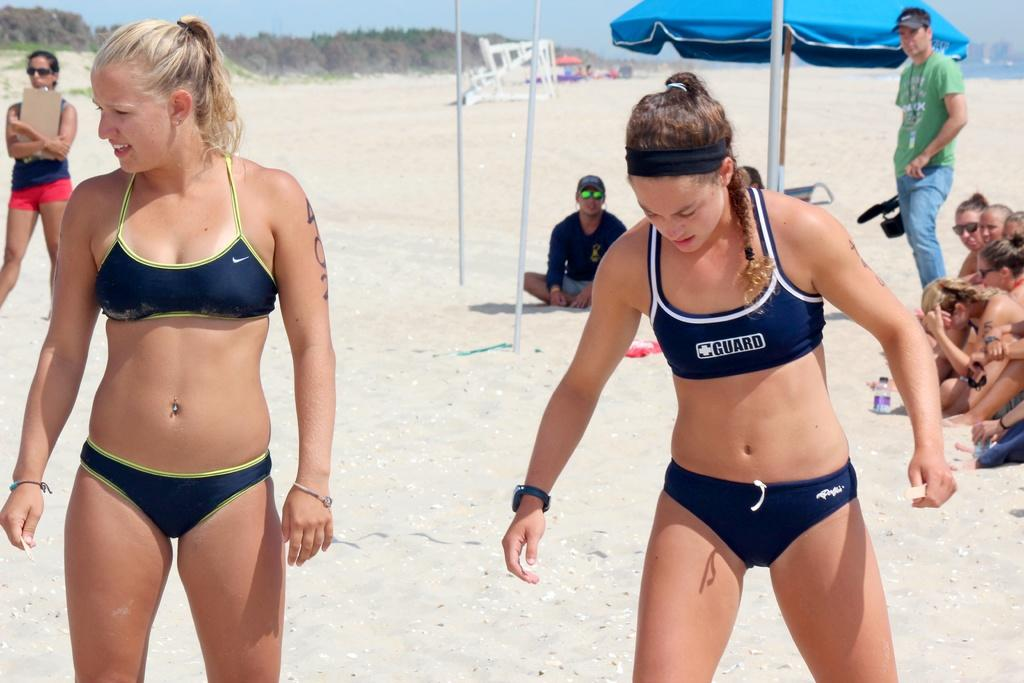<image>
Offer a succinct explanation of the picture presented. Life guard in a blue suit looking down into the sand 